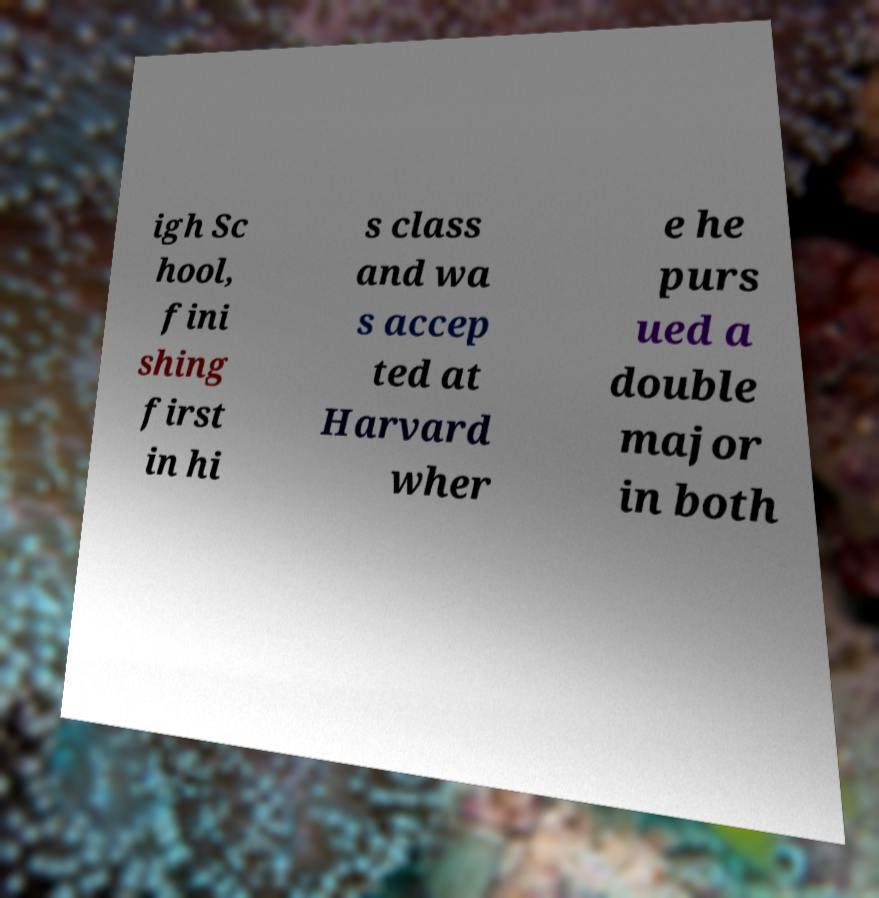Please read and relay the text visible in this image. What does it say? igh Sc hool, fini shing first in hi s class and wa s accep ted at Harvard wher e he purs ued a double major in both 